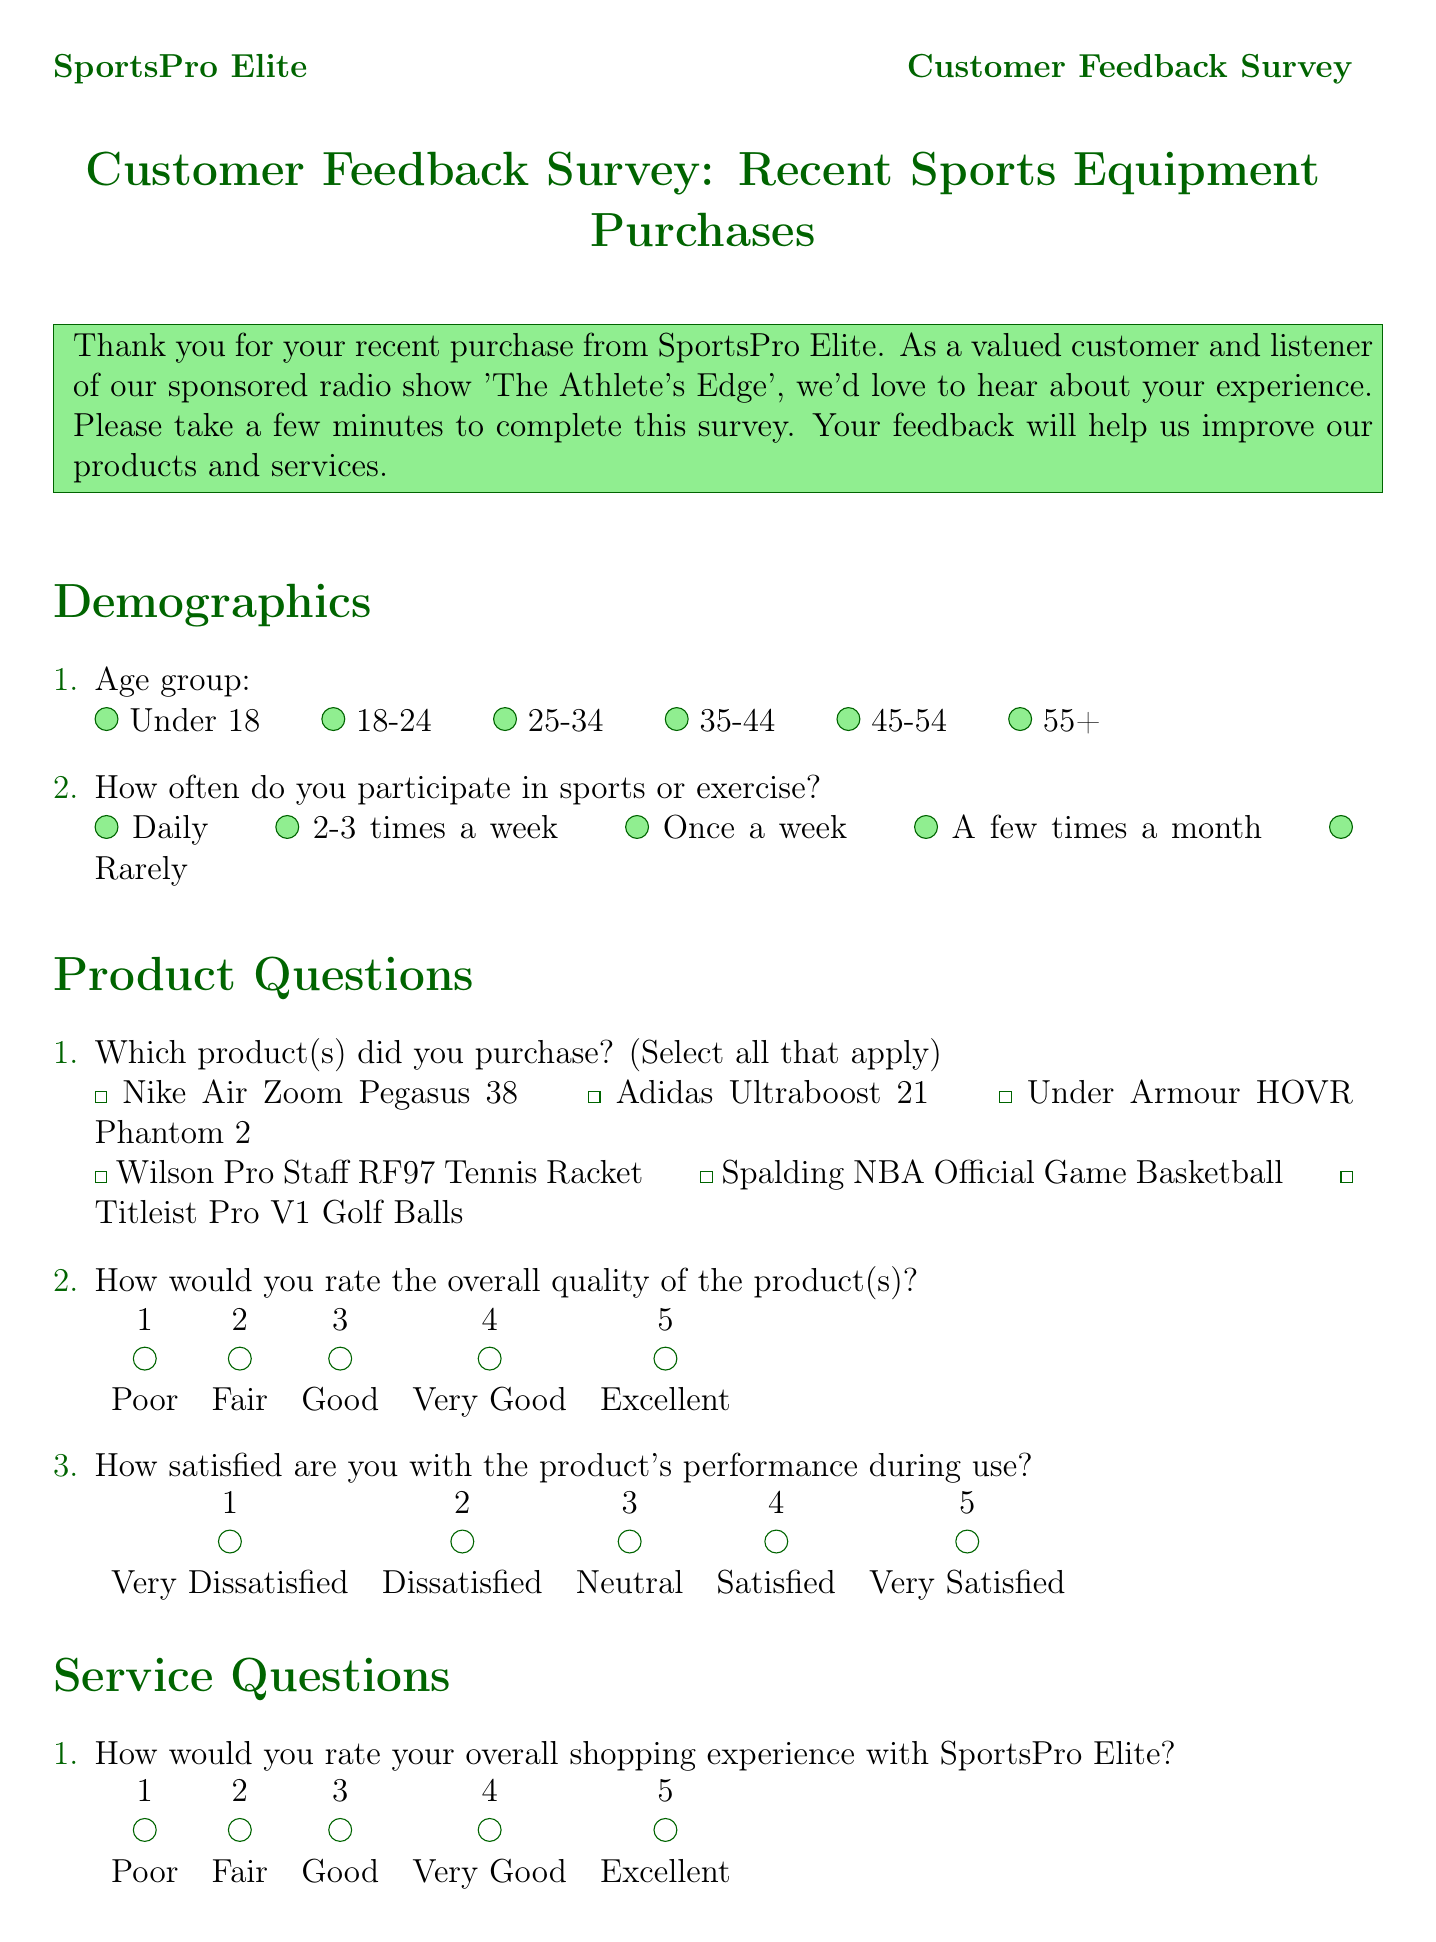What is the name of the company conducting the survey? The company name is mentioned at the top of the document.
Answer: SportsPro Elite What is the title of the survey? The survey title is stated prominently in the document.
Answer: Customer Feedback Survey: Recent Sports Equipment Purchases How many product options are provided for selection? The document lists all the products available for purchase in a checkbox format.
Answer: Six What is the highest rating on the overall quality scale? The highest rating is indicated on the rating scale in the product questions section.
Answer: Excellent What is the minimum rating for the likelihood of recommending SportsPro Elite? The minimum rating is mentioned in the service questions section.
Answer: Zero What do customers need to complete to enter the giveaway? The giveaway section specifies the requirement for entry.
Answer: The survey How long should customers expect to participate in sports or exercise? This is a demographic question with multiple choices listed in the document.
Answer: Daily What radio show is mentioned in the document? The document refers to the show that sponsored the survey.
Answer: The Athlete's Edge What is the reward for completing the survey? The document describes the prize offered for survey completion.
Answer: A $500 SportsPro Elite gift card 